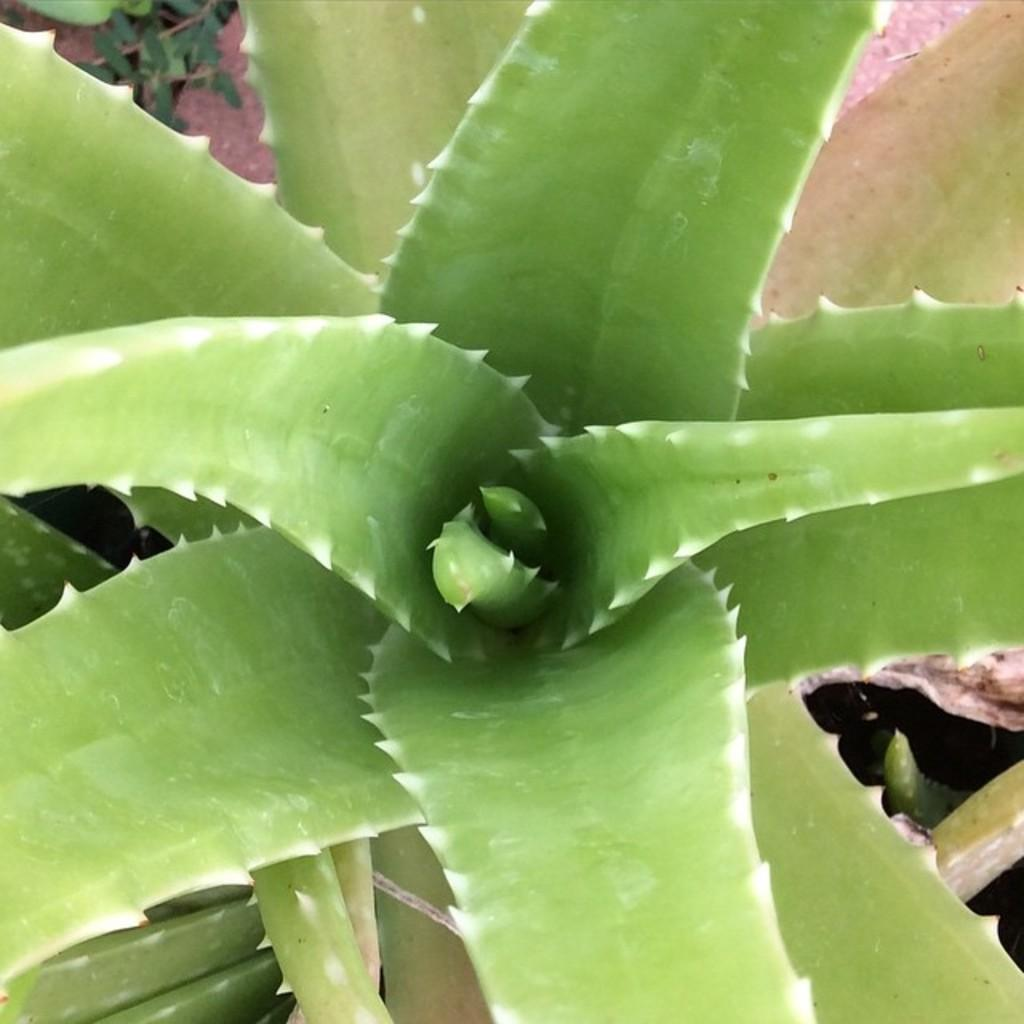What type of plants are in the image? There are Aloe Vera plants in the image. What can be seen in the background of the image? There are leaves in the background of the image. What riddle is being solved by the Aloe Vera plants in the image? There is no riddle being solved by the Aloe Vera plants in the image. 